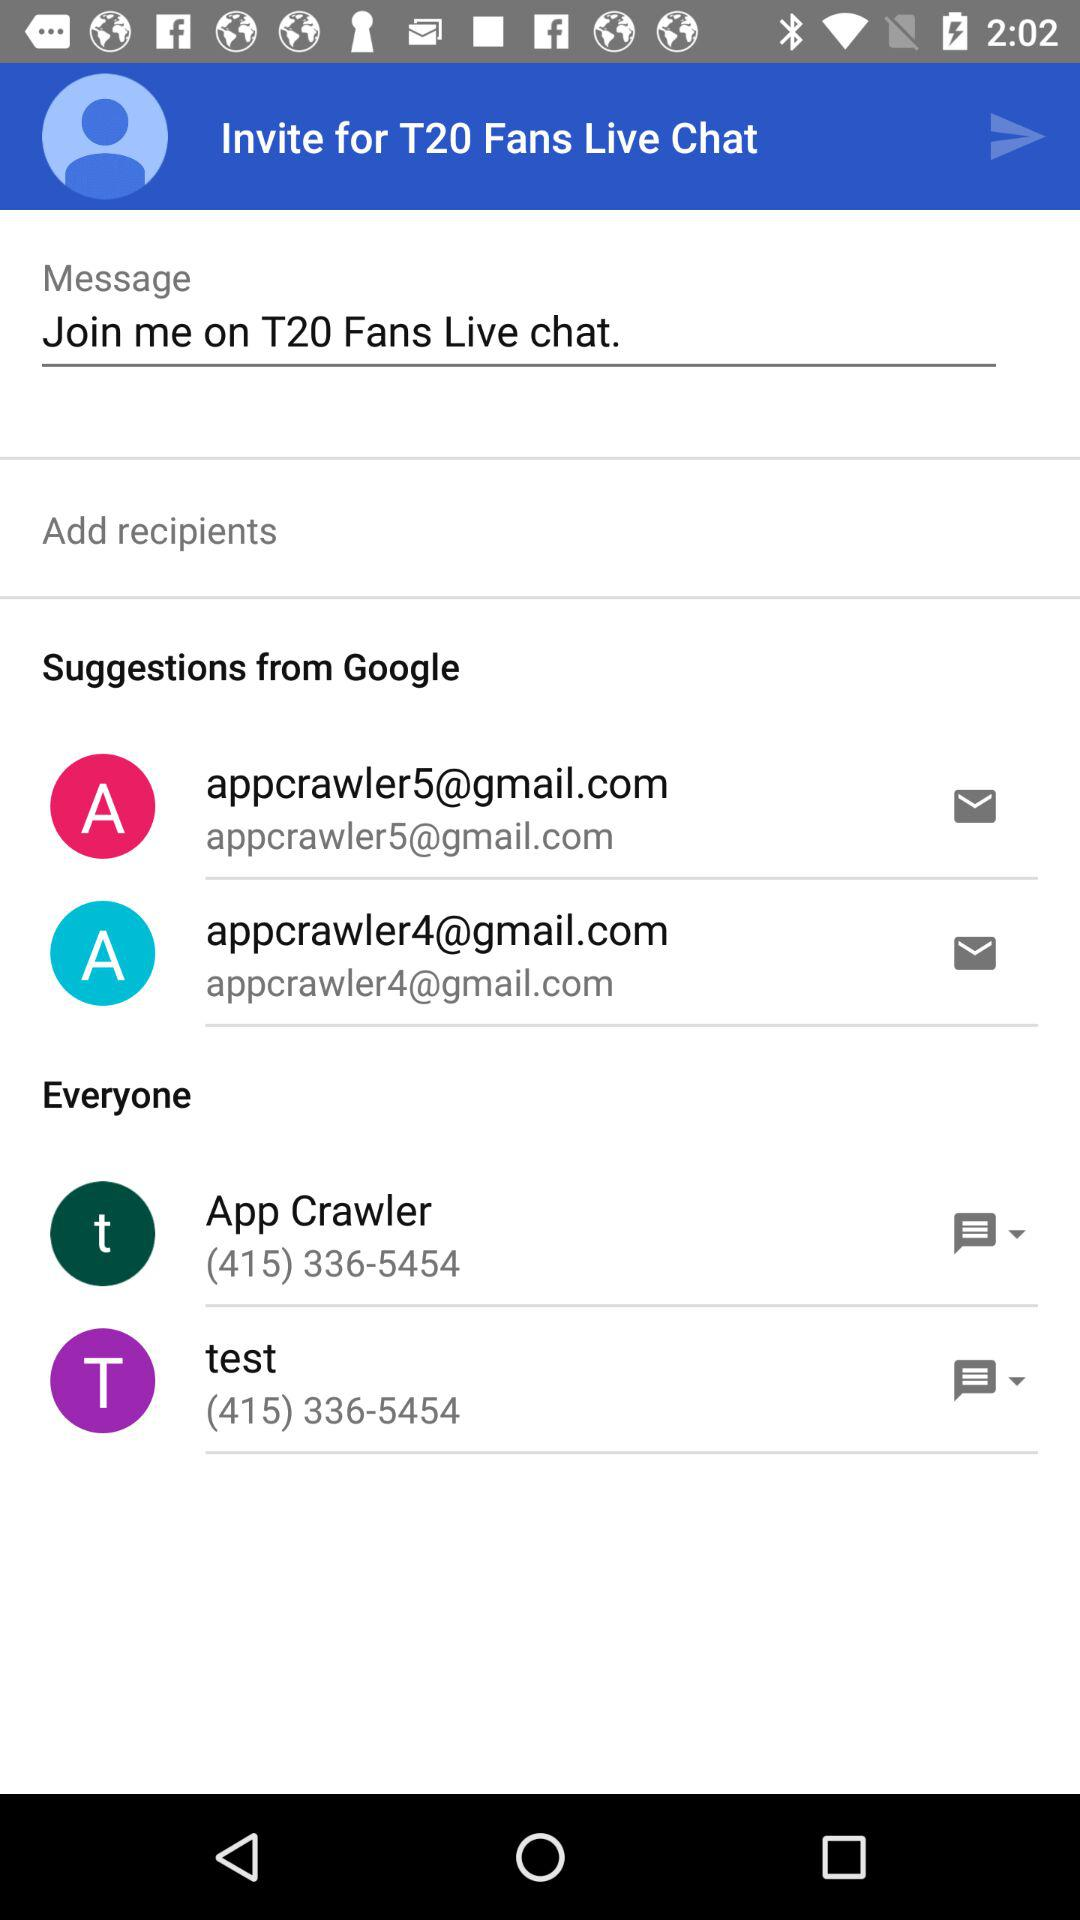Define the contact number of test?
When the provided information is insufficient, respond with <no answer>. <no answer> 